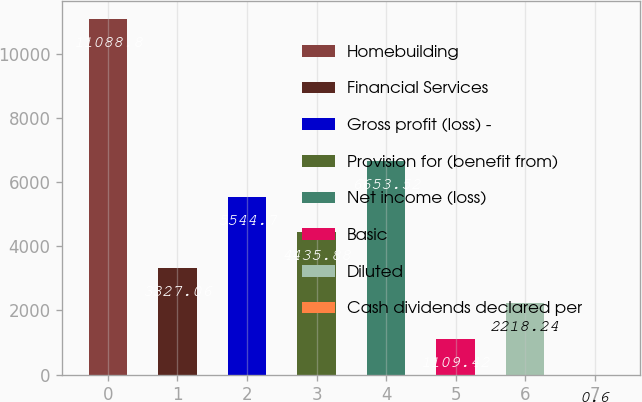Convert chart to OTSL. <chart><loc_0><loc_0><loc_500><loc_500><bar_chart><fcel>Homebuilding<fcel>Financial Services<fcel>Gross profit (loss) -<fcel>Provision for (benefit from)<fcel>Net income (loss)<fcel>Basic<fcel>Diluted<fcel>Cash dividends declared per<nl><fcel>11088.8<fcel>3327.06<fcel>5544.7<fcel>4435.88<fcel>6653.52<fcel>1109.42<fcel>2218.24<fcel>0.6<nl></chart> 